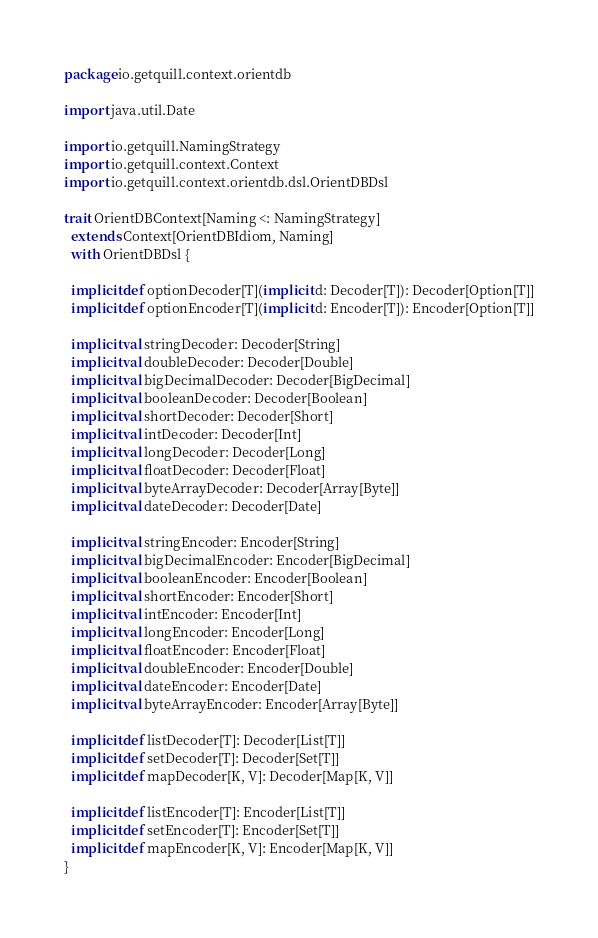<code> <loc_0><loc_0><loc_500><loc_500><_Scala_>package io.getquill.context.orientdb

import java.util.Date

import io.getquill.NamingStrategy
import io.getquill.context.Context
import io.getquill.context.orientdb.dsl.OrientDBDsl

trait OrientDBContext[Naming <: NamingStrategy]
  extends Context[OrientDBIdiom, Naming]
  with OrientDBDsl {

  implicit def optionDecoder[T](implicit d: Decoder[T]): Decoder[Option[T]]
  implicit def optionEncoder[T](implicit d: Encoder[T]): Encoder[Option[T]]

  implicit val stringDecoder: Decoder[String]
  implicit val doubleDecoder: Decoder[Double]
  implicit val bigDecimalDecoder: Decoder[BigDecimal]
  implicit val booleanDecoder: Decoder[Boolean]
  implicit val shortDecoder: Decoder[Short]
  implicit val intDecoder: Decoder[Int]
  implicit val longDecoder: Decoder[Long]
  implicit val floatDecoder: Decoder[Float]
  implicit val byteArrayDecoder: Decoder[Array[Byte]]
  implicit val dateDecoder: Decoder[Date]

  implicit val stringEncoder: Encoder[String]
  implicit val bigDecimalEncoder: Encoder[BigDecimal]
  implicit val booleanEncoder: Encoder[Boolean]
  implicit val shortEncoder: Encoder[Short]
  implicit val intEncoder: Encoder[Int]
  implicit val longEncoder: Encoder[Long]
  implicit val floatEncoder: Encoder[Float]
  implicit val doubleEncoder: Encoder[Double]
  implicit val dateEncoder: Encoder[Date]
  implicit val byteArrayEncoder: Encoder[Array[Byte]]

  implicit def listDecoder[T]: Decoder[List[T]]
  implicit def setDecoder[T]: Decoder[Set[T]]
  implicit def mapDecoder[K, V]: Decoder[Map[K, V]]

  implicit def listEncoder[T]: Encoder[List[T]]
  implicit def setEncoder[T]: Encoder[Set[T]]
  implicit def mapEncoder[K, V]: Encoder[Map[K, V]]
}</code> 